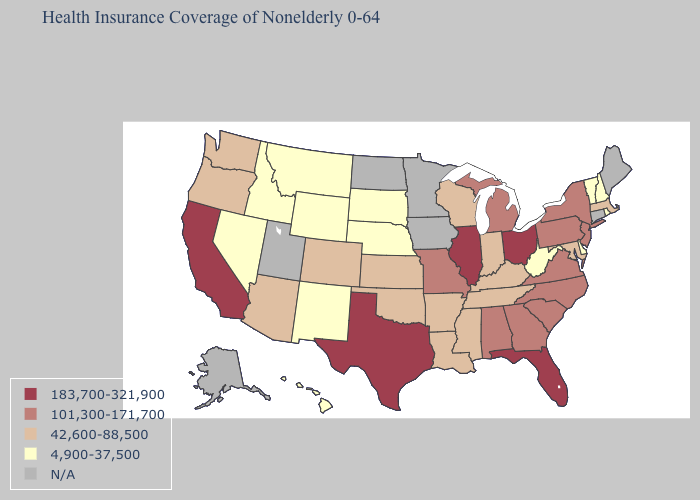Does Georgia have the lowest value in the USA?
Write a very short answer. No. Does the first symbol in the legend represent the smallest category?
Quick response, please. No. Which states hav the highest value in the West?
Write a very short answer. California. Name the states that have a value in the range 101,300-171,700?
Give a very brief answer. Alabama, Georgia, Michigan, Missouri, New Jersey, New York, North Carolina, Pennsylvania, South Carolina, Virginia. Which states hav the highest value in the West?
Answer briefly. California. Is the legend a continuous bar?
Keep it brief. No. Name the states that have a value in the range 4,900-37,500?
Answer briefly. Delaware, Hawaii, Idaho, Montana, Nebraska, Nevada, New Hampshire, New Mexico, Rhode Island, South Dakota, Vermont, West Virginia, Wyoming. Name the states that have a value in the range 183,700-321,900?
Be succinct. California, Florida, Illinois, Ohio, Texas. Among the states that border Indiana , which have the lowest value?
Answer briefly. Kentucky. What is the value of Ohio?
Quick response, please. 183,700-321,900. Name the states that have a value in the range 101,300-171,700?
Write a very short answer. Alabama, Georgia, Michigan, Missouri, New Jersey, New York, North Carolina, Pennsylvania, South Carolina, Virginia. What is the value of Rhode Island?
Short answer required. 4,900-37,500. 